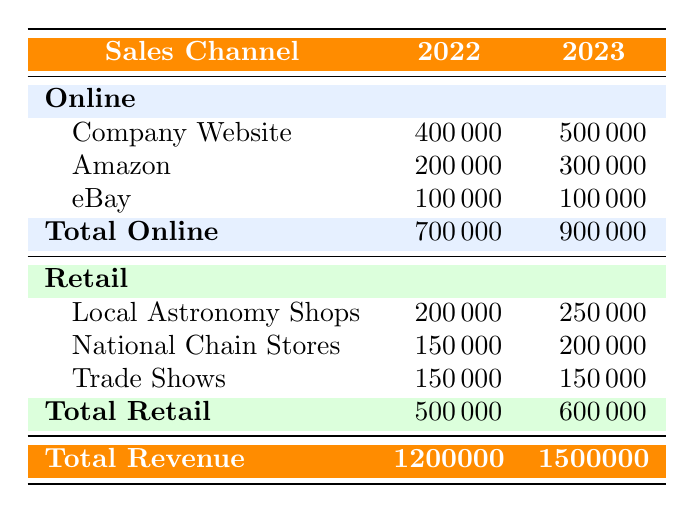What was the total revenue for telescope sales in 2023? The total revenue for telescope sales in 2023 is stated in the last row under the "Total Revenue" section of the table. It shows 1500000.
Answer: 1500000 How much revenue did the Company Website generate in 2022? The revenue generated by the Company Website in 2022 can be found in the "Online" section of the table. It specifically states 400000 for that year.
Answer: 400000 Did eBay's revenue increase from 2022 to 2023? By comparing the eBay revenue values under both years in the table, eBay generated 100000 in both 2022 and 2023, showing no increase.
Answer: No What was the percentage increase in total online sales from 2022 to 2023? The total online sales in 2022 is 700000 and in 2023 is 900000. To find the percentage increase, calculate the difference (900000 - 700000) = 200000. Then divide by the original value (200000 / 700000) and multiply by 100, resulting in approximately 28.57%.
Answer: 28.57% Which retail channel had the highest revenue in 2023? The retail channel revenues for 2023 are as follows: Local Astronomy Shops 250000, National Chain Stores 200000, and Trade Shows 150000. The Local Astronomy Shops generated the highest revenue of 250000.
Answer: Local Astronomy Shops What was the total revenue generated from trade shows in 2022? The revenue from trade shows in 2022 is referenced in the Retail section of the table, where it shows as 150000 under that category.
Answer: 150000 How does the total retail revenue in 2023 compare to 2022? The total retail revenue for 2022 is 500000, while for 2023, it is 600000. The difference is calculated as 600000 - 500000 = 100000, showing an increase in retail revenue.
Answer: Increased by 100000 Was the total online sales in 2023 more than the total retail sales in the same year? In 2023, the total online sales is 900000, and the total retail sales is 600000. Since 900000 > 600000, the total online sales were indeed greater than the retail sales.
Answer: Yes What is the total revenue generated from Amazon in 2022? According to the table, the revenue generated from Amazon in 2022 is listed under the "Online" section, showing a value of 200000.
Answer: 200000 